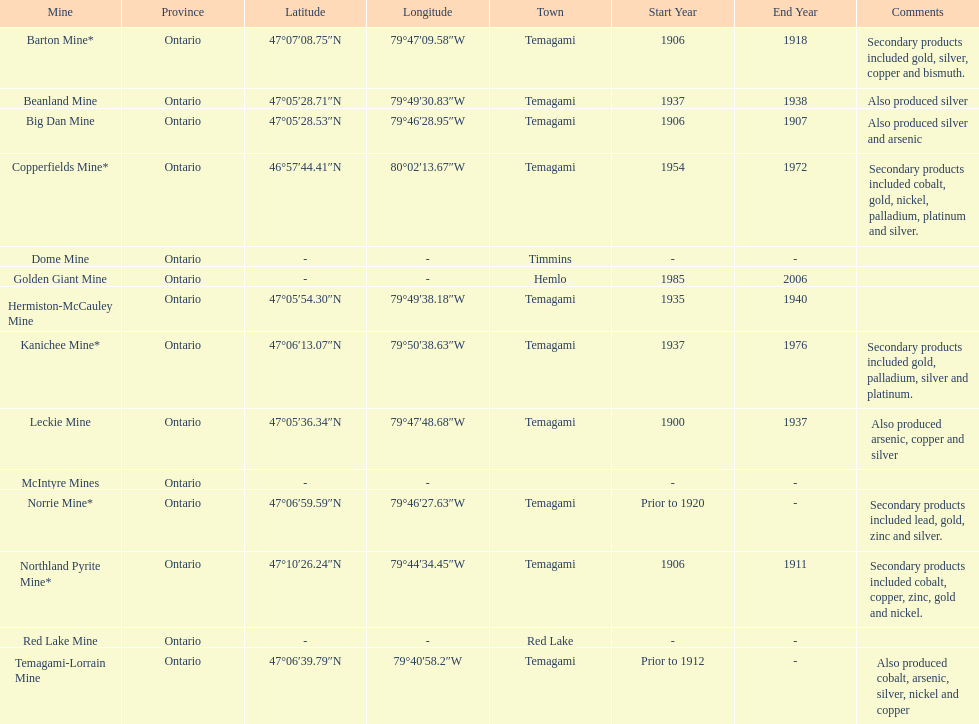What mine is in the town of timmins? Dome Mine. 